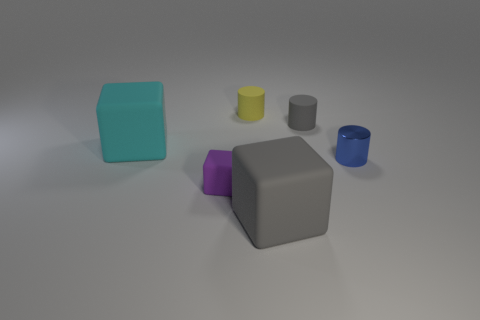What number of other tiny shiny objects have the same color as the shiny object?
Your answer should be compact. 0. Are there fewer big cyan cubes that are on the right side of the tiny shiny object than small yellow things that are behind the gray block?
Give a very brief answer. Yes. What number of gray matte objects are to the left of the big gray object?
Provide a succinct answer. 0. Are there any purple objects made of the same material as the blue cylinder?
Offer a terse response. No. Is the number of tiny yellow rubber cylinders that are to the right of the small yellow cylinder greater than the number of small blue shiny objects that are in front of the blue thing?
Make the answer very short. No. The yellow matte cylinder has what size?
Give a very brief answer. Small. There is a gray object behind the cyan matte object; what is its shape?
Ensure brevity in your answer.  Cylinder. Does the purple thing have the same shape as the big gray object?
Your response must be concise. Yes. Are there an equal number of big cyan matte cubes that are right of the shiny object and cyan cubes?
Provide a short and direct response. No. What is the shape of the tiny gray matte thing?
Keep it short and to the point. Cylinder. 